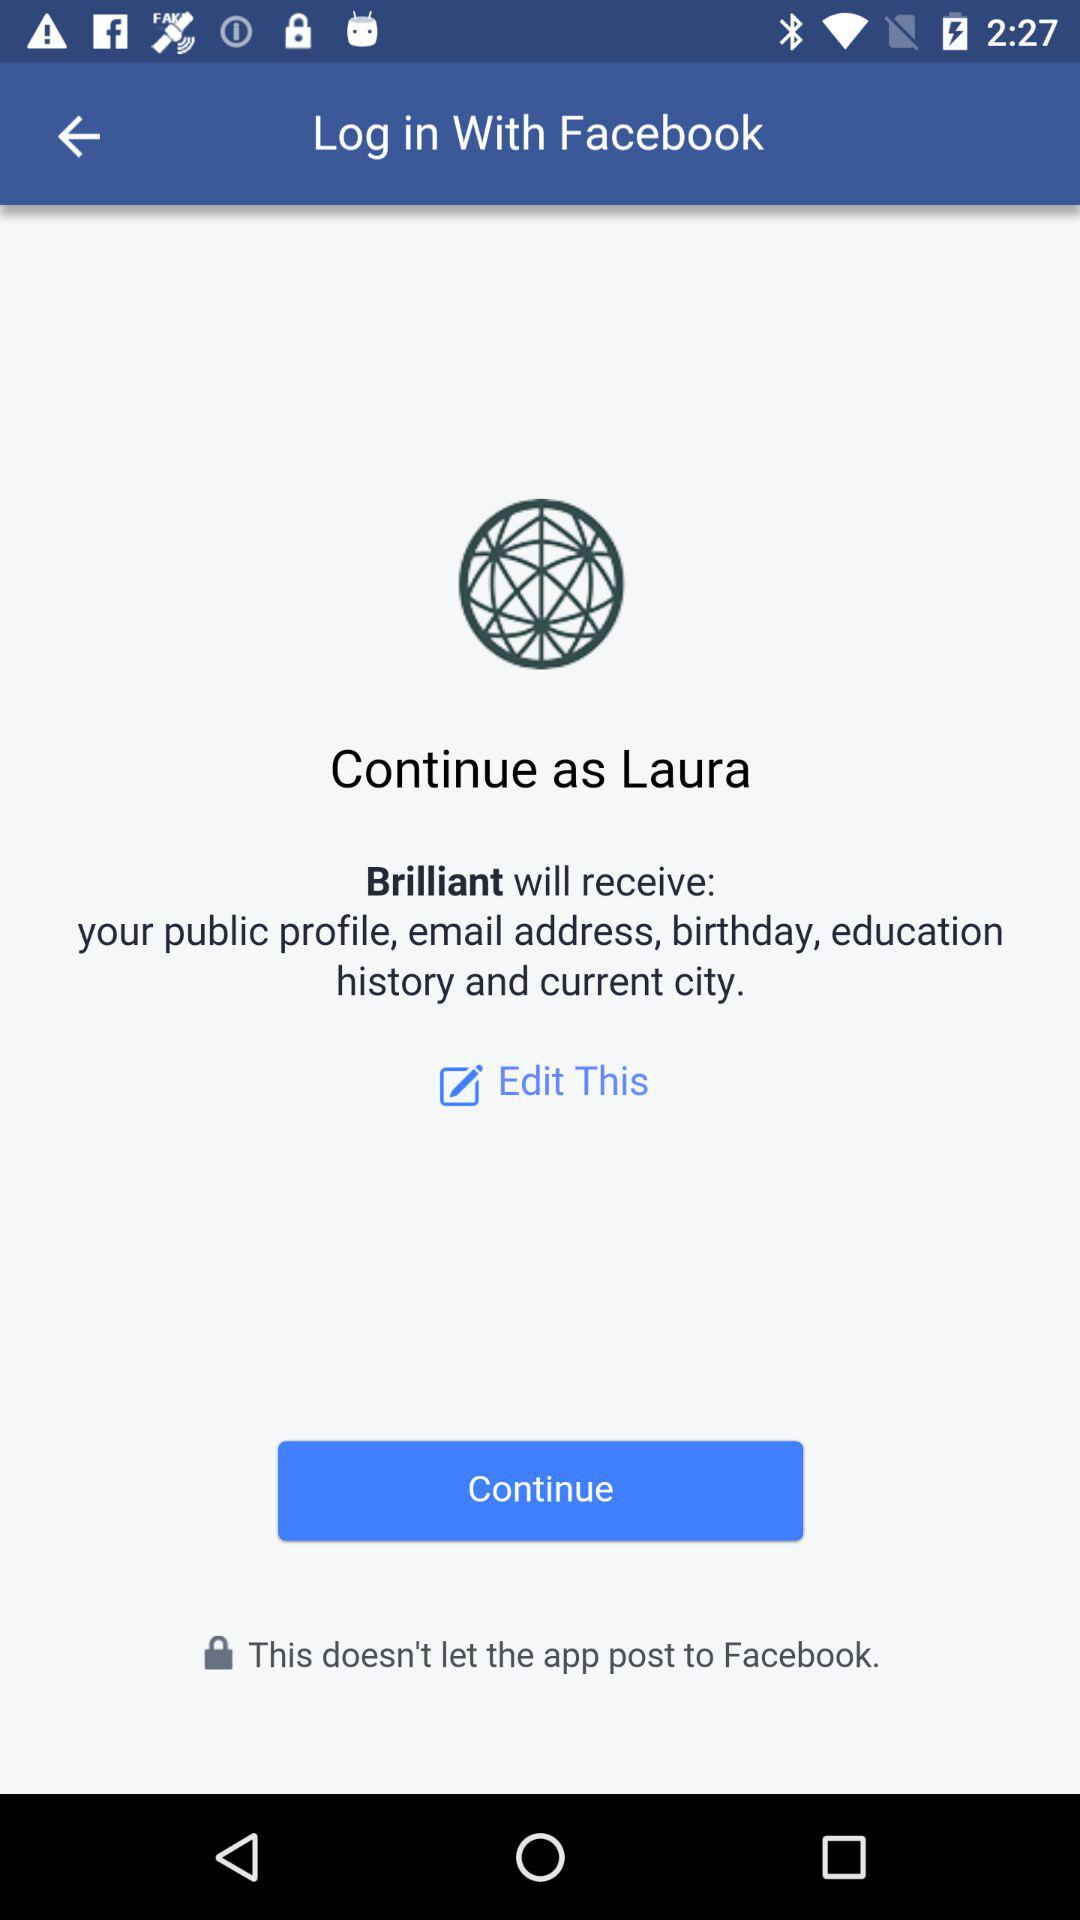What information will Brilliant receive? Brilliant receive your public profile, email address, birthday, education history and current city. 